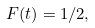<formula> <loc_0><loc_0><loc_500><loc_500>F ( t ) = 1 / 2 ,</formula> 